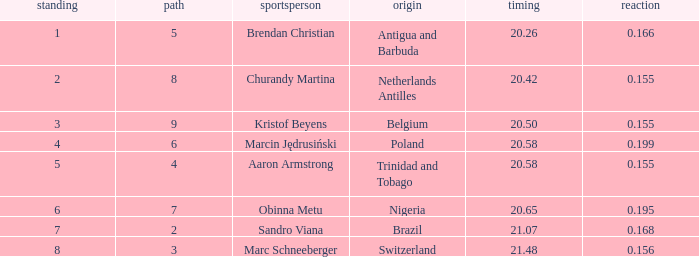Which Lane has a Time larger than 20.5, and a Nationality of trinidad and tobago? 4.0. 